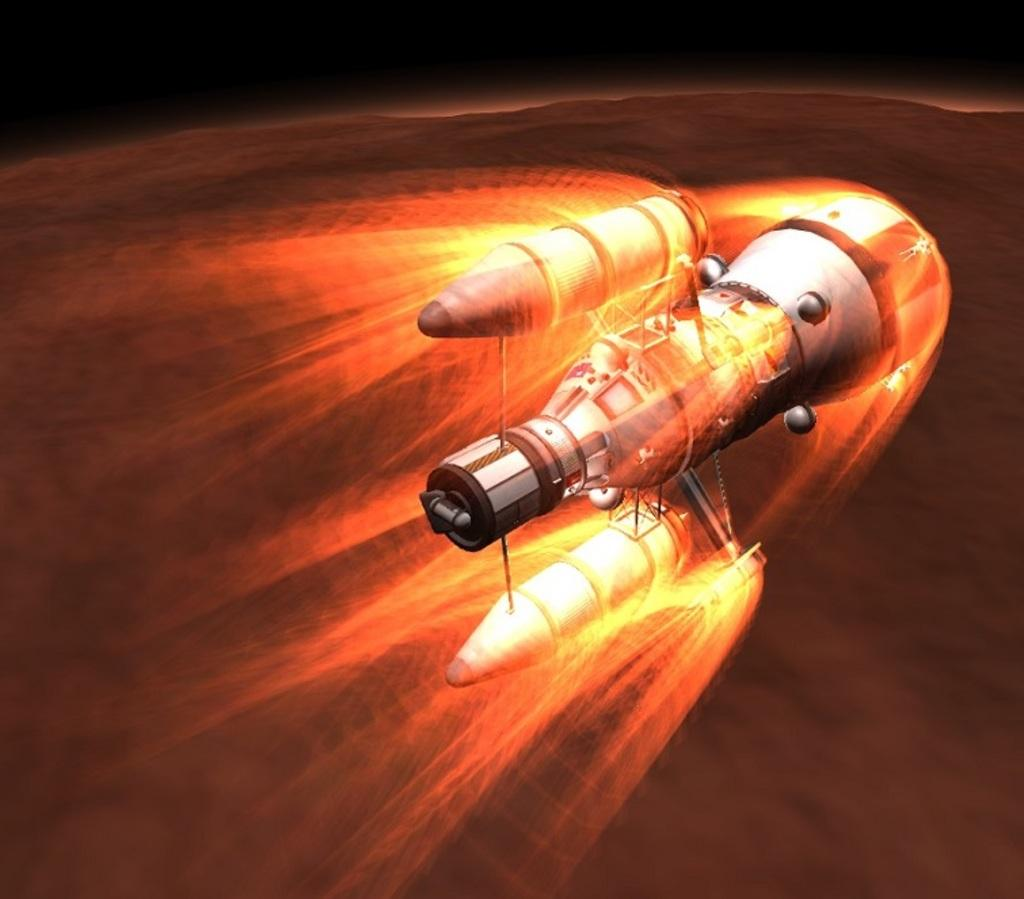What is the main subject of the image? The main subject of the image is a satellite. How many chickens are visible in the image? There are no chickens present in the image; it features a satellite. What type of yak can be seen interacting with the satellite in the image? There is no yak present in the image; only the satellite is visible. 